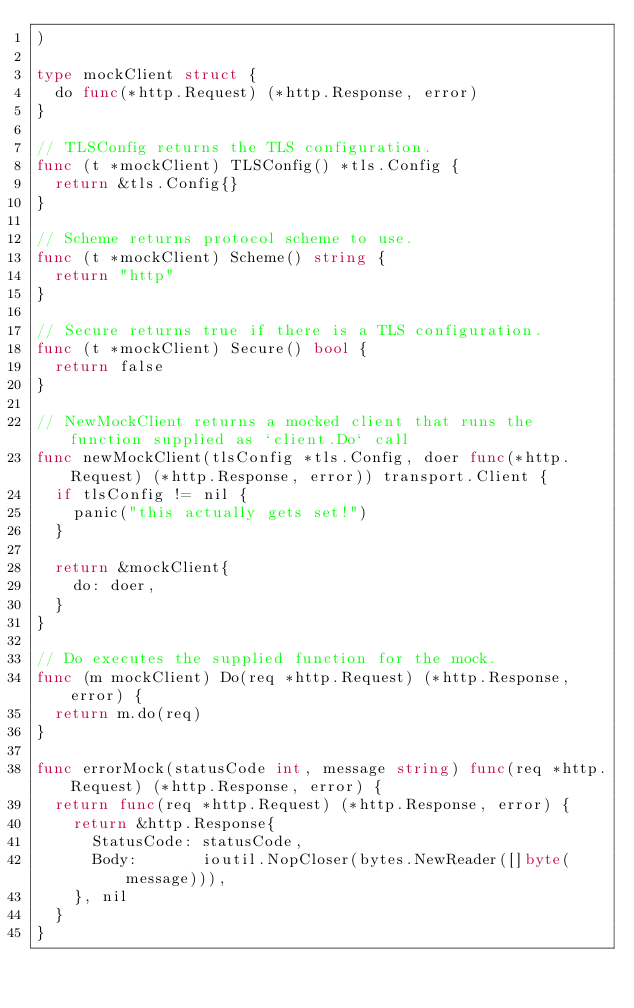<code> <loc_0><loc_0><loc_500><loc_500><_Go_>)

type mockClient struct {
	do func(*http.Request) (*http.Response, error)
}

// TLSConfig returns the TLS configuration.
func (t *mockClient) TLSConfig() *tls.Config {
	return &tls.Config{}
}

// Scheme returns protocol scheme to use.
func (t *mockClient) Scheme() string {
	return "http"
}

// Secure returns true if there is a TLS configuration.
func (t *mockClient) Secure() bool {
	return false
}

// NewMockClient returns a mocked client that runs the function supplied as `client.Do` call
func newMockClient(tlsConfig *tls.Config, doer func(*http.Request) (*http.Response, error)) transport.Client {
	if tlsConfig != nil {
		panic("this actually gets set!")
	}

	return &mockClient{
		do: doer,
	}
}

// Do executes the supplied function for the mock.
func (m mockClient) Do(req *http.Request) (*http.Response, error) {
	return m.do(req)
}

func errorMock(statusCode int, message string) func(req *http.Request) (*http.Response, error) {
	return func(req *http.Request) (*http.Response, error) {
		return &http.Response{
			StatusCode: statusCode,
			Body:       ioutil.NopCloser(bytes.NewReader([]byte(message))),
		}, nil
	}
}
</code> 